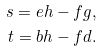Convert formula to latex. <formula><loc_0><loc_0><loc_500><loc_500>s = e h - f g , \\ t = b h - f d .</formula> 